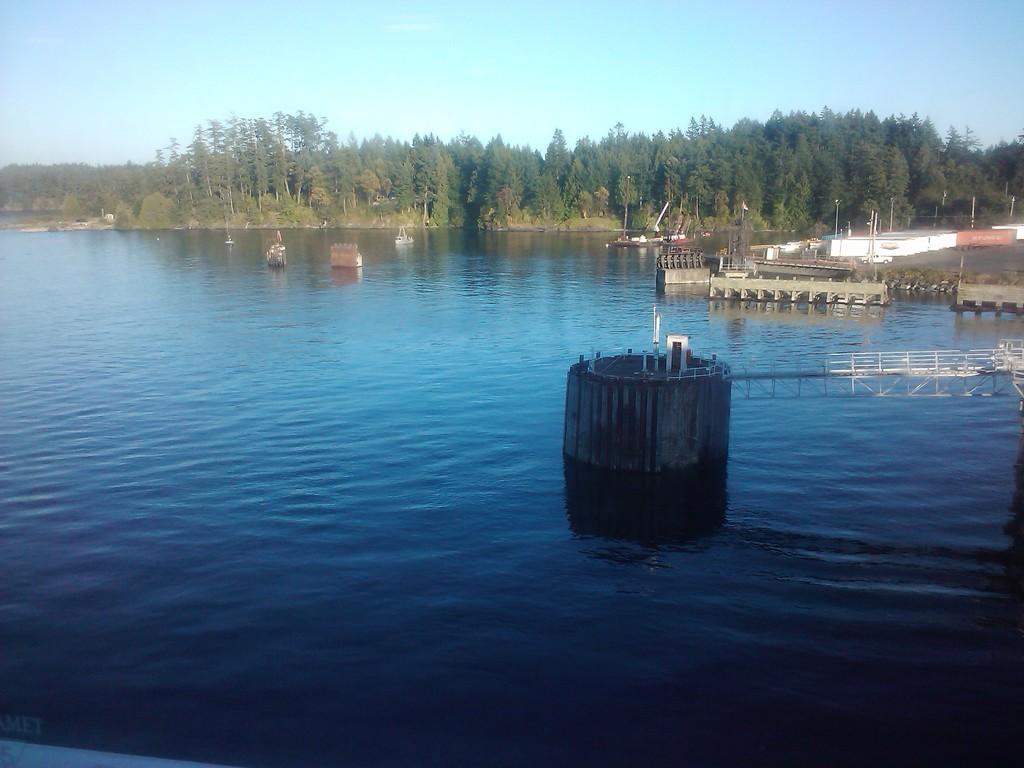Describe this image in one or two sentences. In this image I can see few boats on the water. To the right I can see the containers. In the background I can see many trees and the sky. 